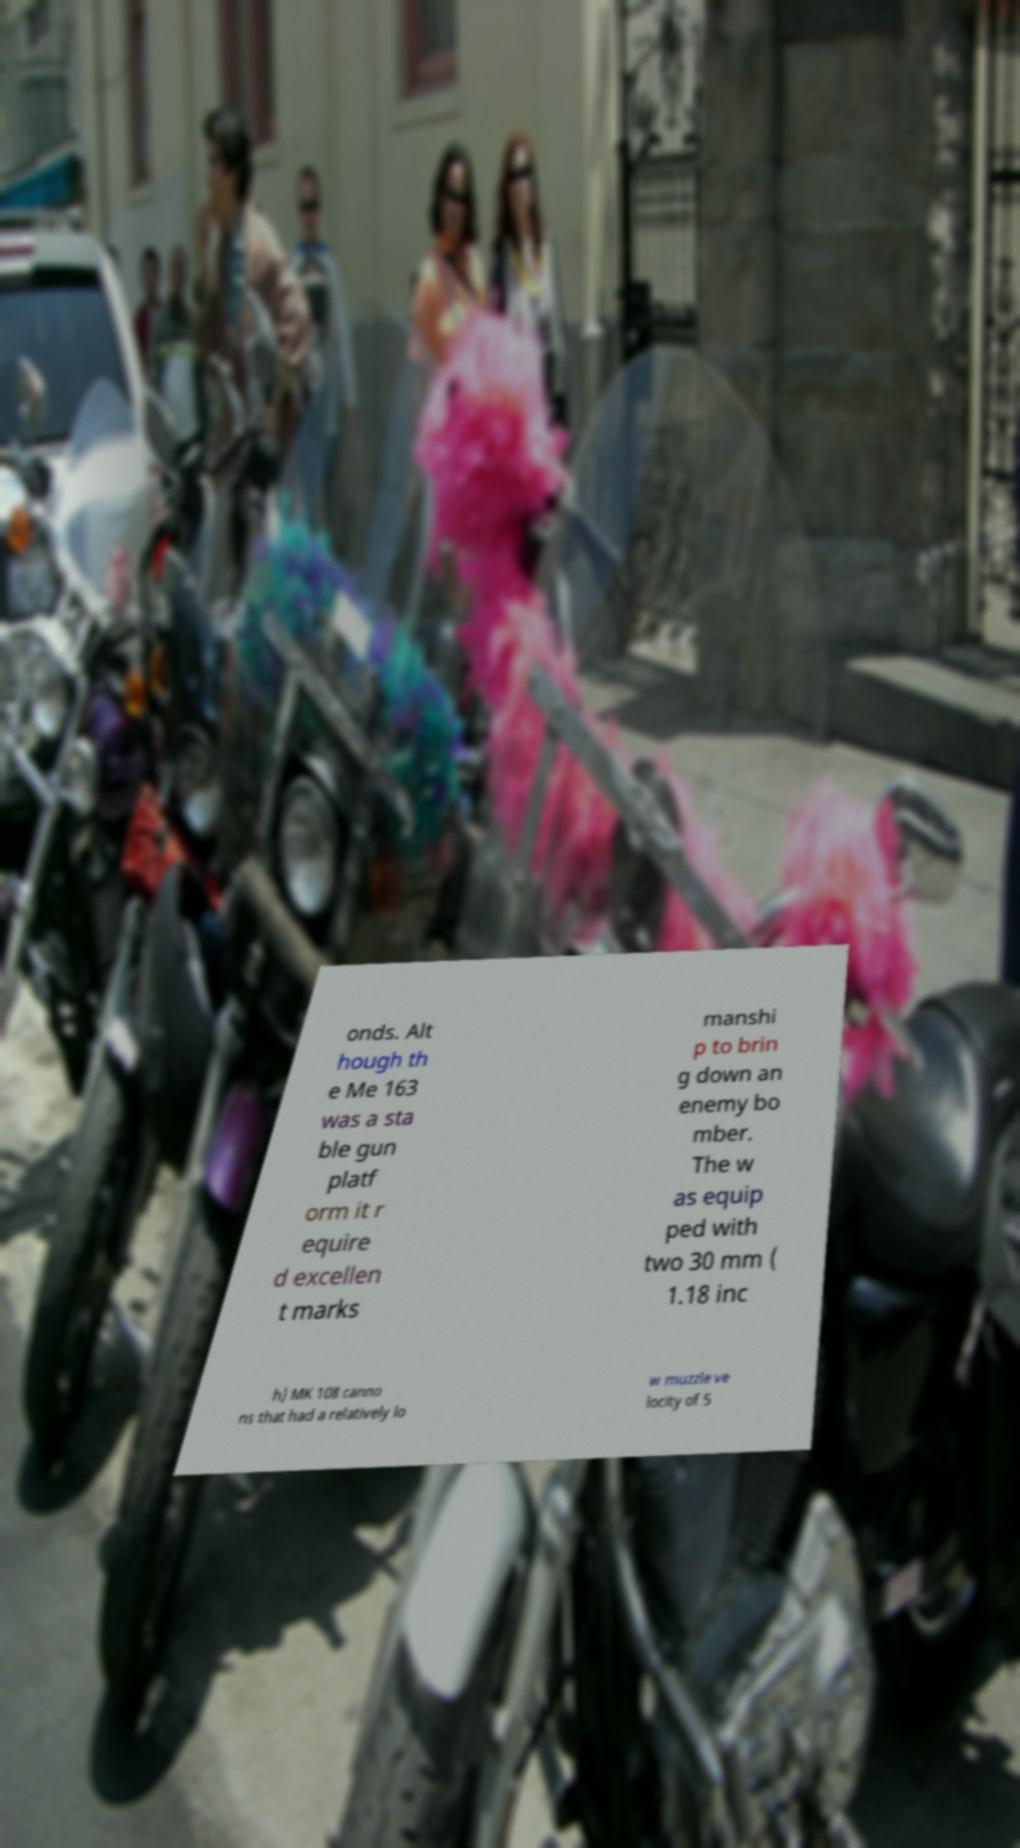Can you accurately transcribe the text from the provided image for me? onds. Alt hough th e Me 163 was a sta ble gun platf orm it r equire d excellen t marks manshi p to brin g down an enemy bo mber. The w as equip ped with two 30 mm ( 1.18 inc h) MK 108 canno ns that had a relatively lo w muzzle ve locity of 5 